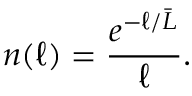Convert formula to latex. <formula><loc_0><loc_0><loc_500><loc_500>n ( \ell ) = { \frac { e ^ { - \ell / { \bar { L } } } } { \ell } } .</formula> 